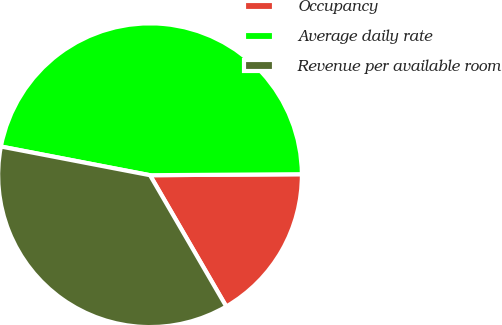Convert chart. <chart><loc_0><loc_0><loc_500><loc_500><pie_chart><fcel>Occupancy<fcel>Average daily rate<fcel>Revenue per available room<nl><fcel>16.73%<fcel>46.87%<fcel>36.4%<nl></chart> 